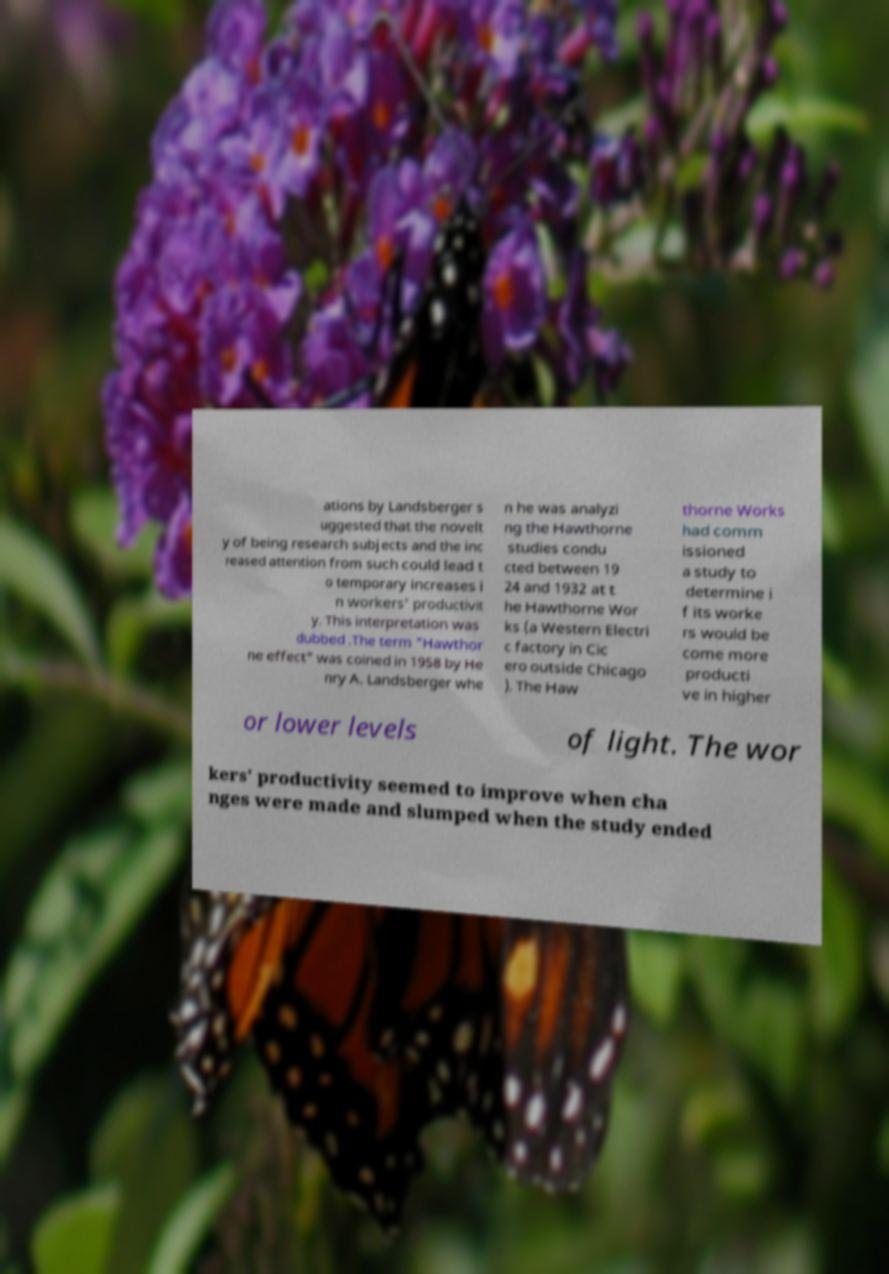Can you read and provide the text displayed in the image?This photo seems to have some interesting text. Can you extract and type it out for me? ations by Landsberger s uggested that the novelt y of being research subjects and the inc reased attention from such could lead t o temporary increases i n workers' productivit y. This interpretation was dubbed .The term "Hawthor ne effect" was coined in 1958 by He nry A. Landsberger whe n he was analyzi ng the Hawthorne studies condu cted between 19 24 and 1932 at t he Hawthorne Wor ks (a Western Electri c factory in Cic ero outside Chicago ). The Haw thorne Works had comm issioned a study to determine i f its worke rs would be come more producti ve in higher or lower levels of light. The wor kers' productivity seemed to improve when cha nges were made and slumped when the study ended 